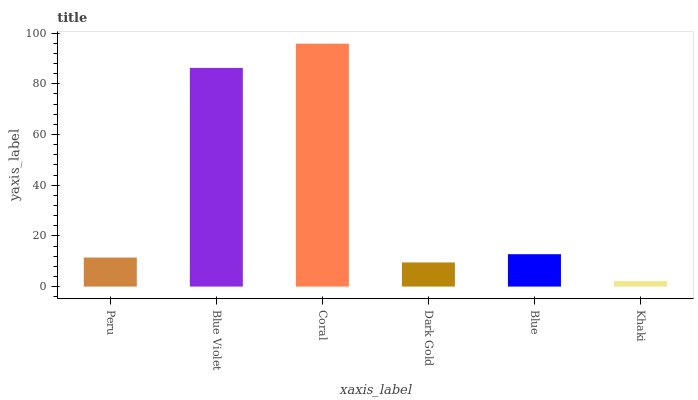Is Khaki the minimum?
Answer yes or no. Yes. Is Coral the maximum?
Answer yes or no. Yes. Is Blue Violet the minimum?
Answer yes or no. No. Is Blue Violet the maximum?
Answer yes or no. No. Is Blue Violet greater than Peru?
Answer yes or no. Yes. Is Peru less than Blue Violet?
Answer yes or no. Yes. Is Peru greater than Blue Violet?
Answer yes or no. No. Is Blue Violet less than Peru?
Answer yes or no. No. Is Blue the high median?
Answer yes or no. Yes. Is Peru the low median?
Answer yes or no. Yes. Is Dark Gold the high median?
Answer yes or no. No. Is Coral the low median?
Answer yes or no. No. 